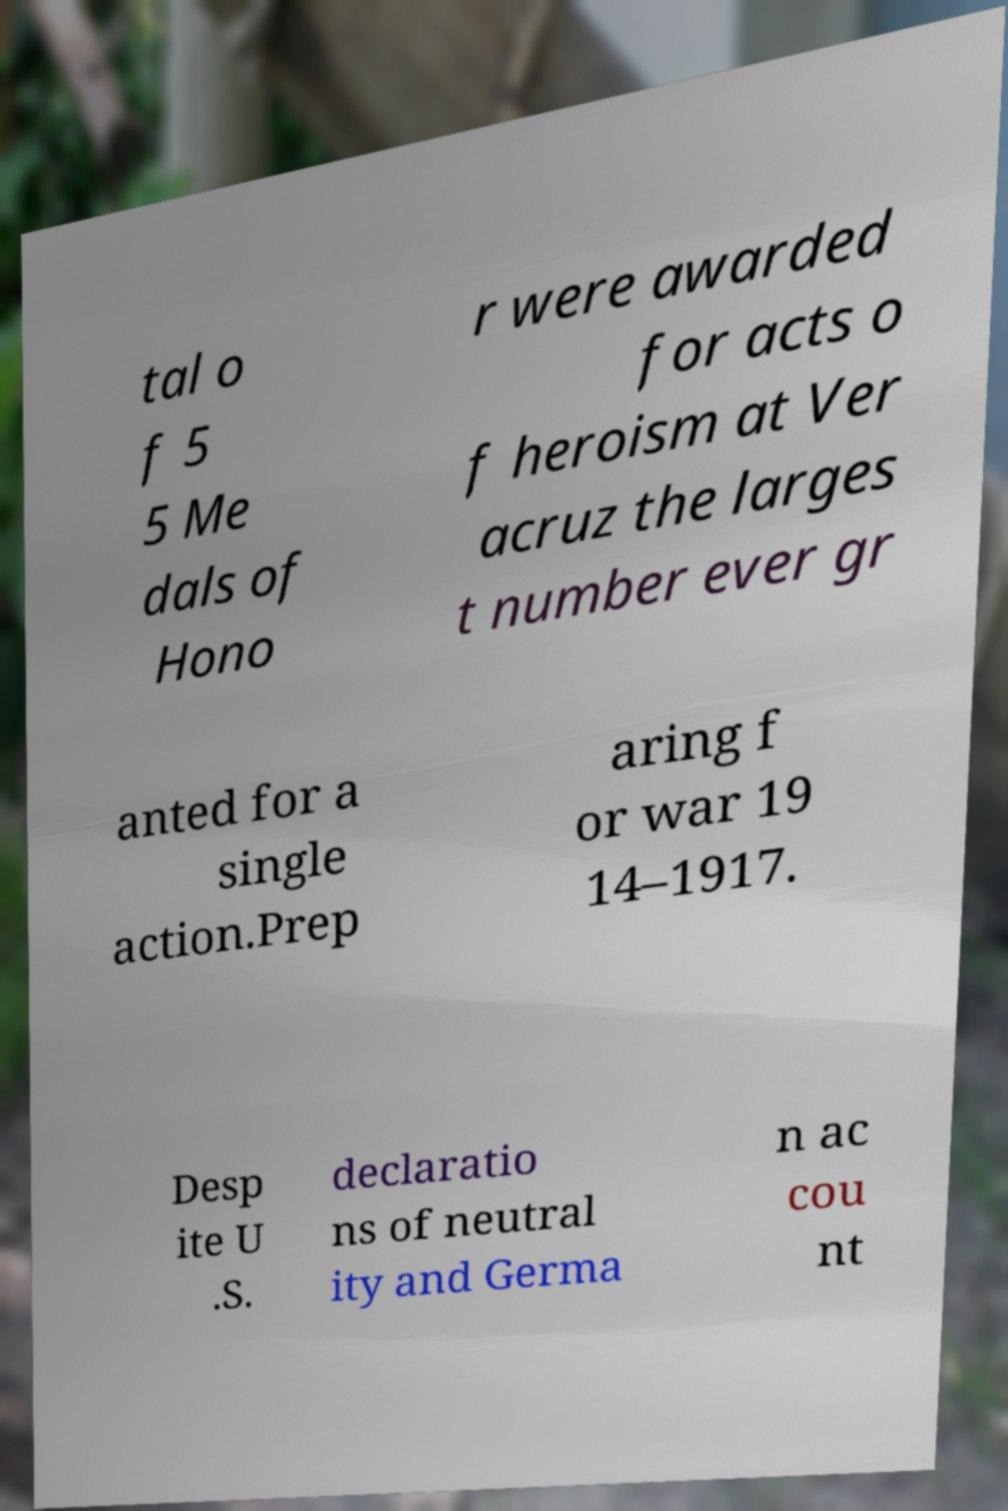Can you accurately transcribe the text from the provided image for me? tal o f 5 5 Me dals of Hono r were awarded for acts o f heroism at Ver acruz the larges t number ever gr anted for a single action.Prep aring f or war 19 14–1917. Desp ite U .S. declaratio ns of neutral ity and Germa n ac cou nt 